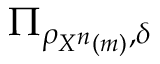<formula> <loc_0><loc_0><loc_500><loc_500>\Pi _ { \rho _ { X ^ { n } \left ( m \right ) } , \delta }</formula> 